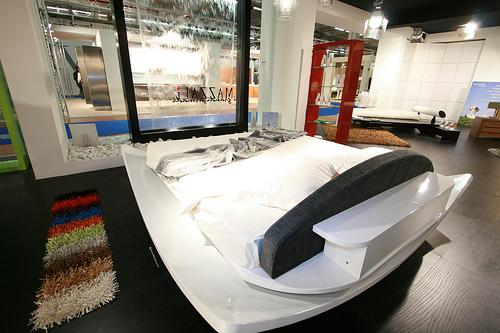Mention the variety of light fixtures and their position in the image. There are illuminated white and metallic silver light fixtures located near the top of the image. Write a sentence about the color and shape of the area rug. The area rug has a vibrant color scheme and an irregular shape, featuring many different colors. Describe the appearance of the bed in the given image. The bed has a black and white design, with a large white base, a grey headboard, and is covered in a gray blanket. Briefly describe the wall and shelf visible in the image. The wall is white, adorned with a blue and green poster, and supports a white shelf next to an empty white shelf attached to a bed. Mention the flooring and how it complements the rug in the picture. The flooring is made of brown hardwood, which contrasts and highlights the colorful rug placed on it. What is the dominating color theme of furniture visible in the image? The color theme of the furniture includes red, white, and black. State the appearance of the floor and a decorative item placed upon it. The floor is made of brown hardwood, with a colorful area rug adding visual interest to the space. What is unique about the placement of the shelf mentioned in the image? The empty white shelf is uniquely attached to the bed, providing a space-efficient storage solution. Briefly mention the three most prominent objects in the image. A black and white bed, a red bookshelf, and a multicolored stripe carpet stand out in the image. Identify the key furniture pieces in the image and mention their colors. The key furniture pieces include a black and white bed, a red bookshelf, and a lime green shelf. 